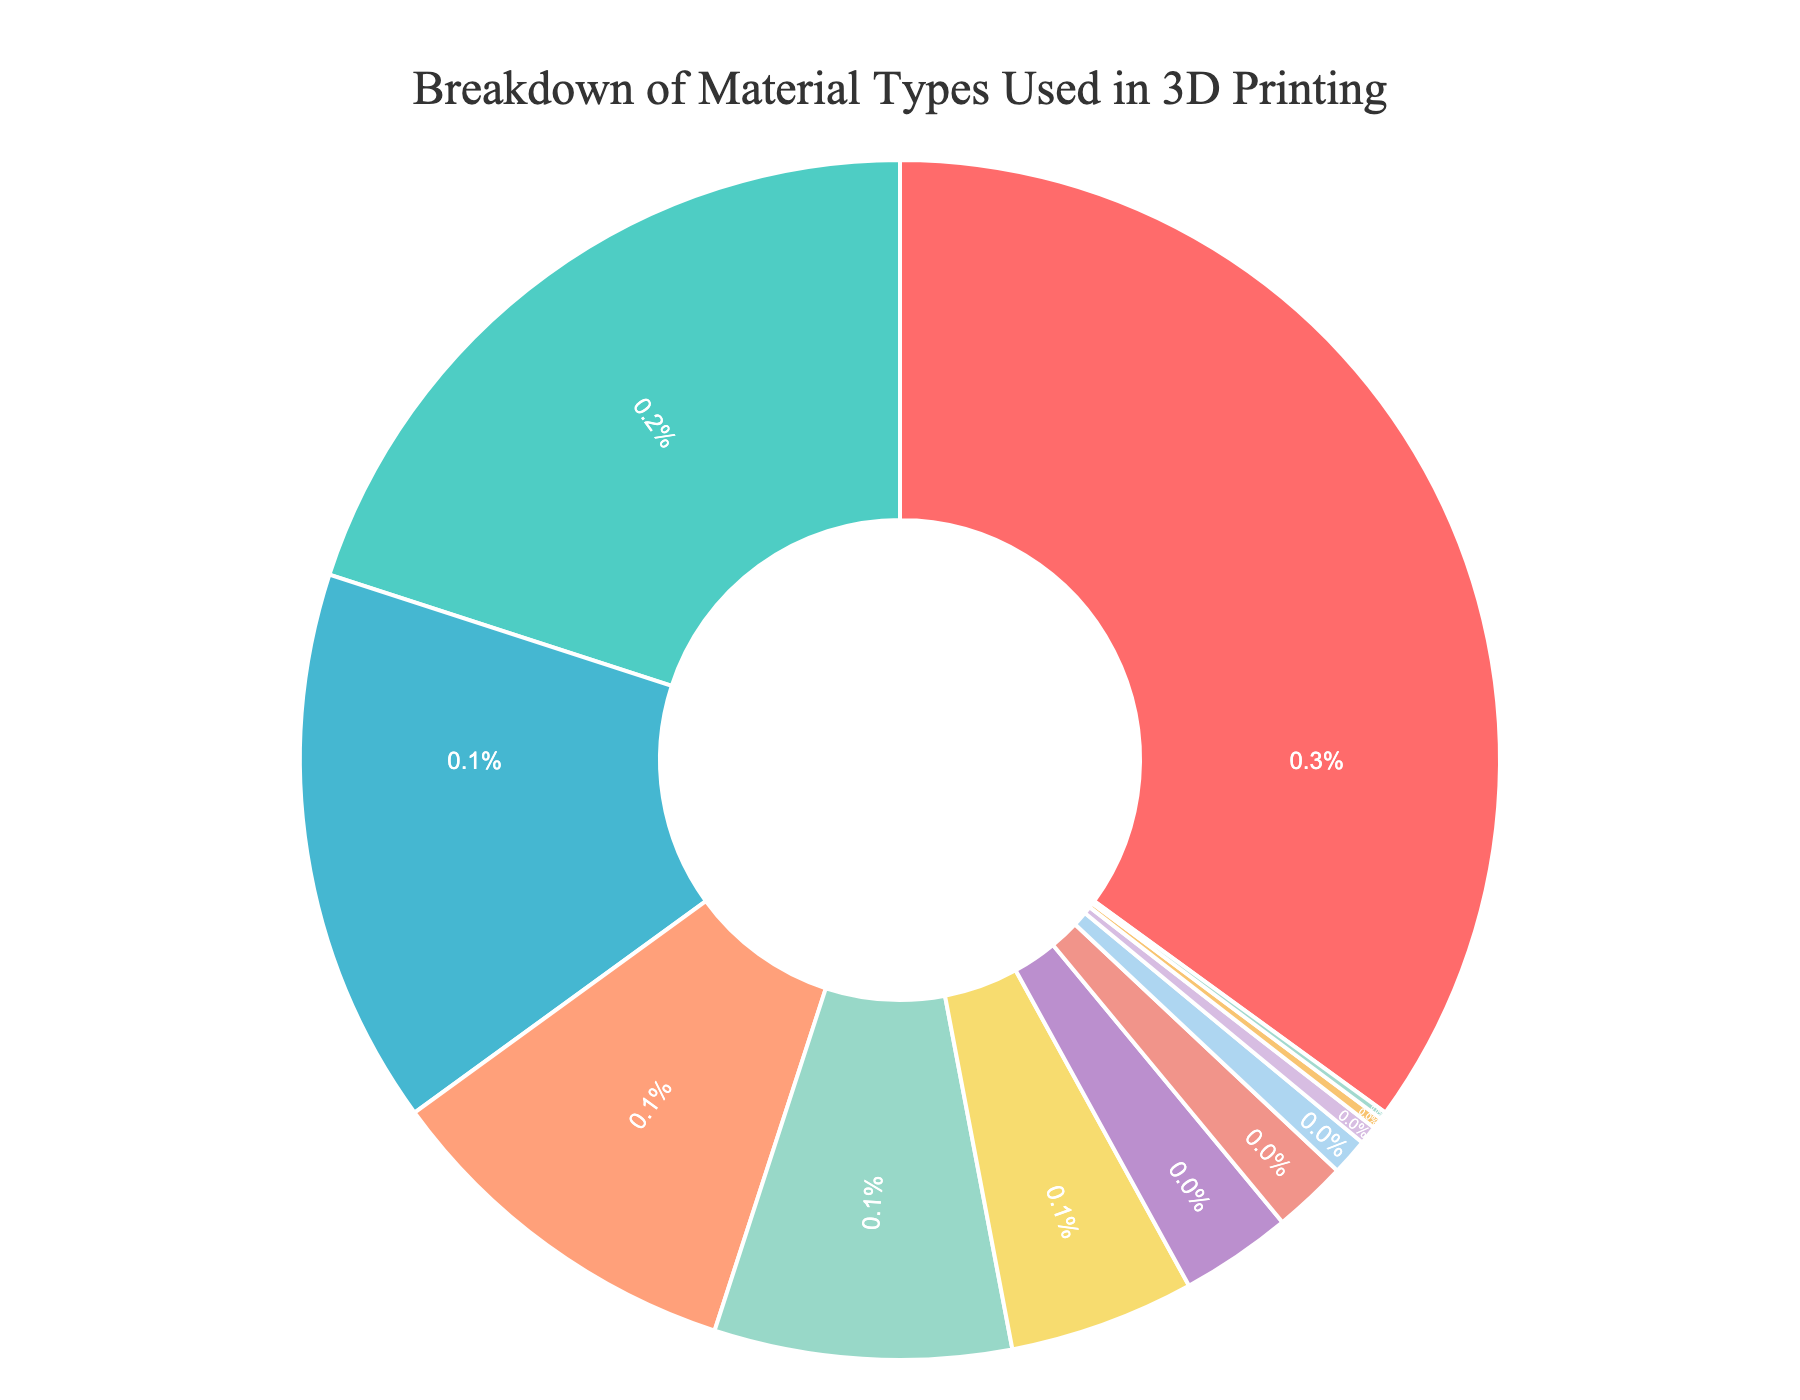Which material has the highest usage percentage in 3D printing? The largest segment in the pie chart, indicated by its biggest size, represents the material with the highest usage percentage
Answer: PLA What is the combined percentage of Nylon, PC (Polycarbonate), and PEEK? To find the combined percentage, sum the individual percentages: Nylon (5%) + PC (3%) + PEEK (2%) = 10%
Answer: 10% Is Resin usage more or less common than PETG? By comparing the size and respective percentages of the segments representing Resin and PETG, we see that PETG has 15%, while Resin has 8%. Therefore, Resin is less common.
Answer: Less common What is the difference in percentage usage between ABS and TPU/TPE? Find the individual percentages for ABS and TPU/TPE and subtract: ABS (20%) - TPU/TPE (10%) = 10%
Answer: 10% What percentage of materials used in 3D printing are infused filaments (Metal, Wood, and Carbon fiber)? Sum the percentages of the infused filaments categories: Metal (1%) + Wood (0.5%) + Carbon fiber (0.3%) = 1.8%
Answer: 1.8% How does the usage of metal-infused filaments compare to PEEK? Metal-infused filaments (1%) have a smaller segment compared to PEEK (2%) in the pie chart, indicating less usage.
Answer: Less usage Which material type has the smallest usage percentage, and what is it? The smallest segment in the pie chart is the smallest slice, which represents the material type with the smallest usage percentage: Ceramic-based materials (0.2%)
Answer: Ceramic-based materials If PLA and ABS are combined, what percentage of 3D printing materials do they represent? Add the two percentages together: PLA (35%) + ABS (20%) = 55%
Answer: 55% How many material types have a usage percentage above 10%? Identify and count the segments with percentages above 10%. These segments are PLA (35%), ABS (20%), PETG (15%), and TPU/TPE (10%). So, there are four material types.
Answer: Four What’s the total percentage of all non-infused filament materials (excluding Metal, Wood, and Carbon fiber)? Subtract the summed percentages of Metal, Wood, and Carbon fiber from the total 100%: 100% - 1% - 0.5% - 0.3% = 98.2%
Answer: 98.2% 